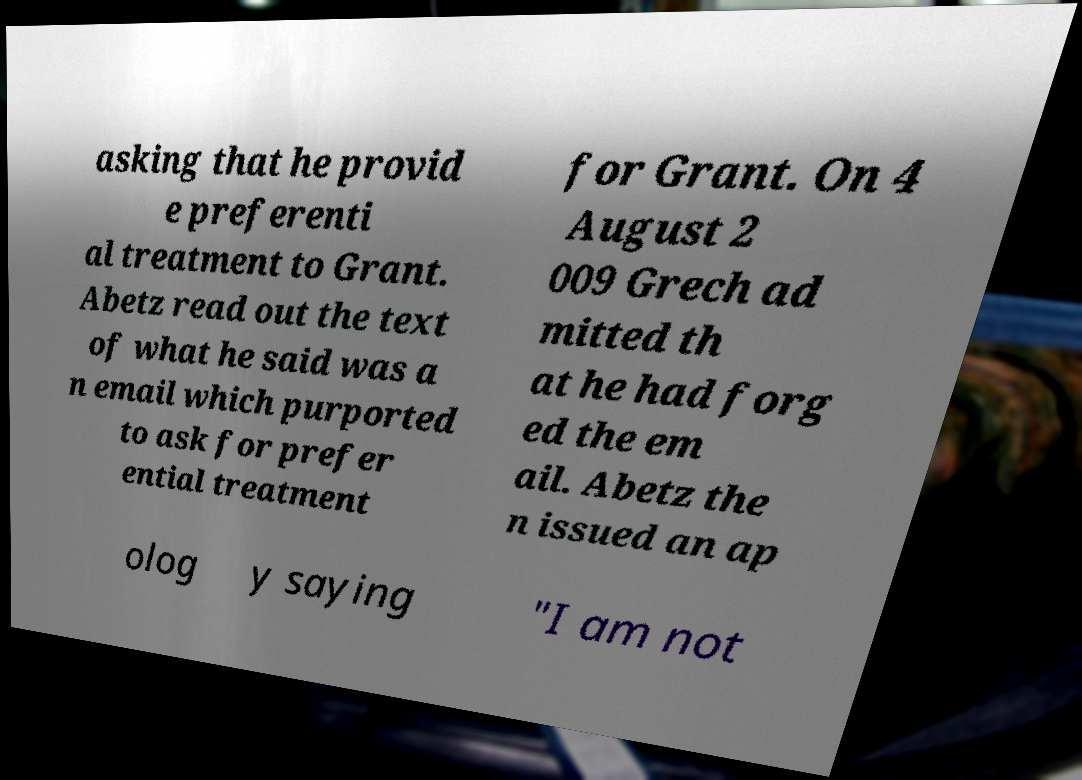Can you read and provide the text displayed in the image?This photo seems to have some interesting text. Can you extract and type it out for me? asking that he provid e preferenti al treatment to Grant. Abetz read out the text of what he said was a n email which purported to ask for prefer ential treatment for Grant. On 4 August 2 009 Grech ad mitted th at he had forg ed the em ail. Abetz the n issued an ap olog y saying "I am not 